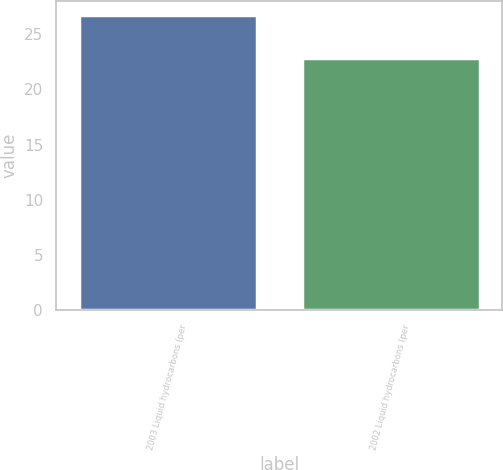<chart> <loc_0><loc_0><loc_500><loc_500><bar_chart><fcel>2003 Liquid hydrocarbons (per<fcel>2002 Liquid hydrocarbons (per<nl><fcel>26.72<fcel>22.86<nl></chart> 